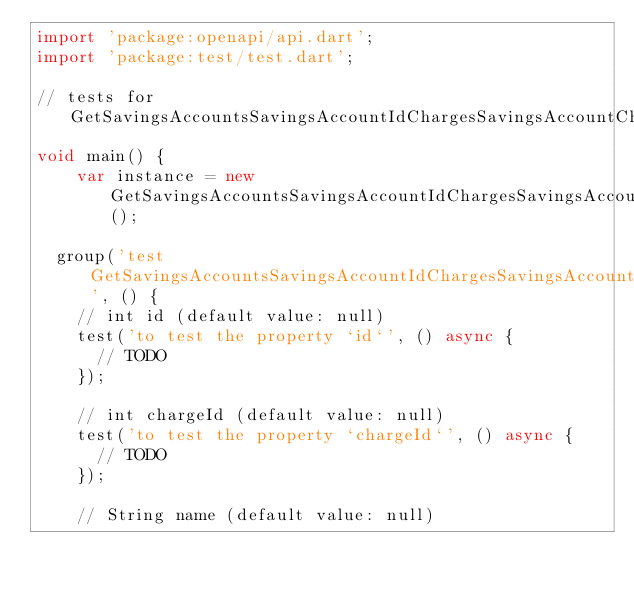<code> <loc_0><loc_0><loc_500><loc_500><_Dart_>import 'package:openapi/api.dart';
import 'package:test/test.dart';

// tests for GetSavingsAccountsSavingsAccountIdChargesSavingsAccountChargeIdResponse
void main() {
    var instance = new GetSavingsAccountsSavingsAccountIdChargesSavingsAccountChargeIdResponse();

  group('test GetSavingsAccountsSavingsAccountIdChargesSavingsAccountChargeIdResponse', () {
    // int id (default value: null)
    test('to test the property `id`', () async {
      // TODO
    });

    // int chargeId (default value: null)
    test('to test the property `chargeId`', () async {
      // TODO
    });

    // String name (default value: null)</code> 